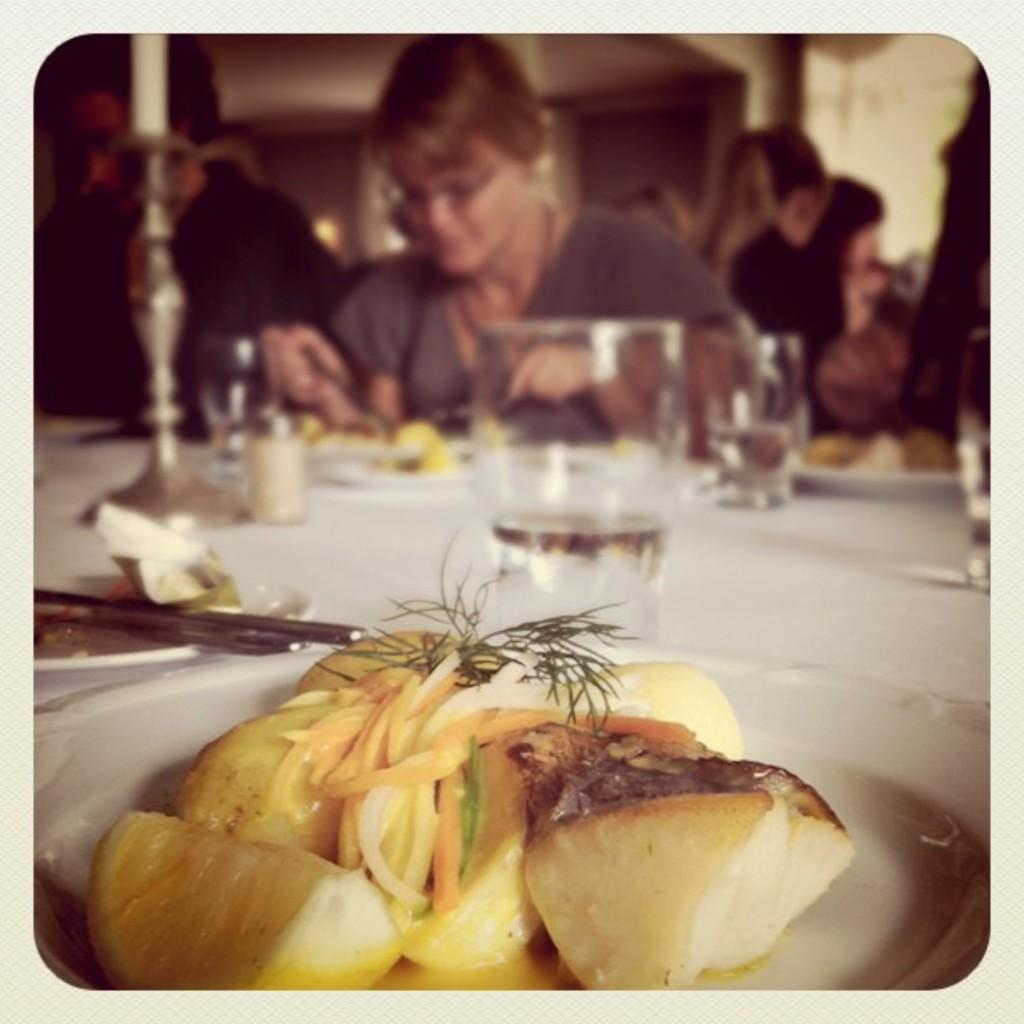What can be found on the table in the image? There are plates, food, and glasses on the table. What else is present on the table? There are other objects on the table. Can you describe the background of the image? The background of the image is blurry. Are there any people visible in the image? Yes, there are people visible in the background. What type of cannon is being used in the hospital depicted in the image? There is no cannon or hospital present in the image; it features a table with various objects and a blurry background. How many stems are visible in the image? There is no mention of stems in the image, so it is not possible to determine their presence or quantity. 